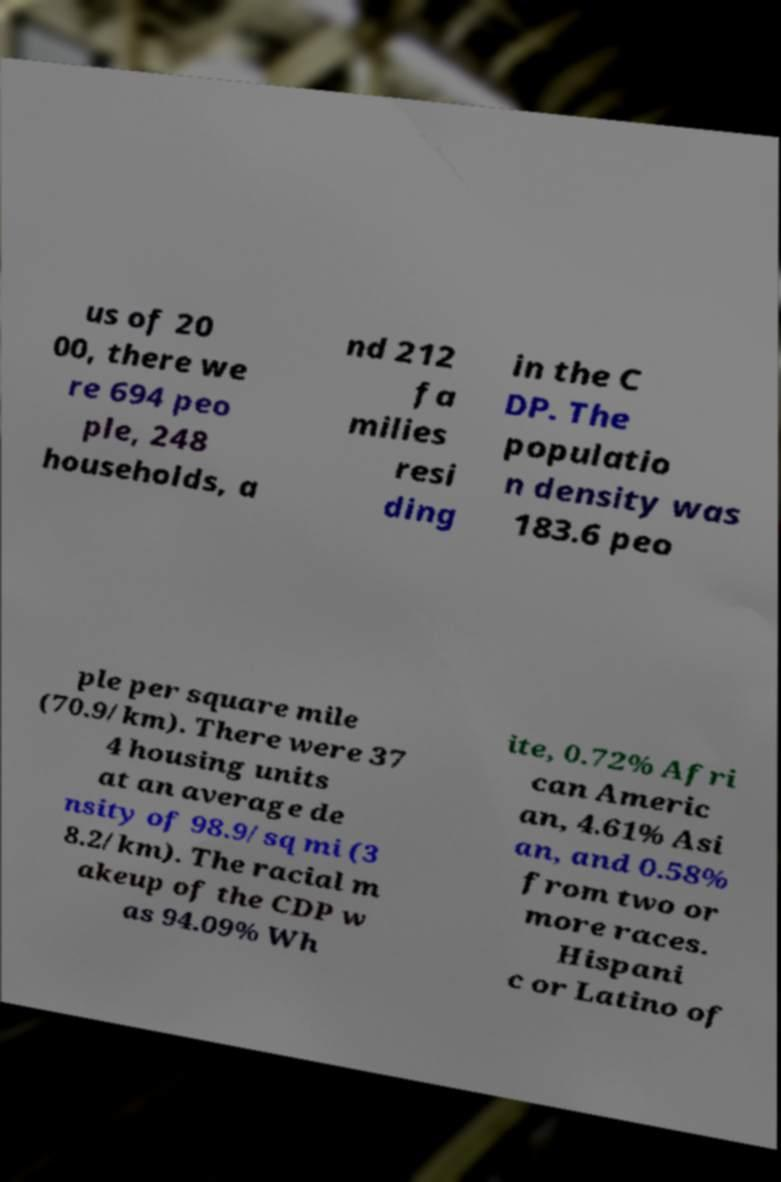Can you accurately transcribe the text from the provided image for me? us of 20 00, there we re 694 peo ple, 248 households, a nd 212 fa milies resi ding in the C DP. The populatio n density was 183.6 peo ple per square mile (70.9/km). There were 37 4 housing units at an average de nsity of 98.9/sq mi (3 8.2/km). The racial m akeup of the CDP w as 94.09% Wh ite, 0.72% Afri can Americ an, 4.61% Asi an, and 0.58% from two or more races. Hispani c or Latino of 